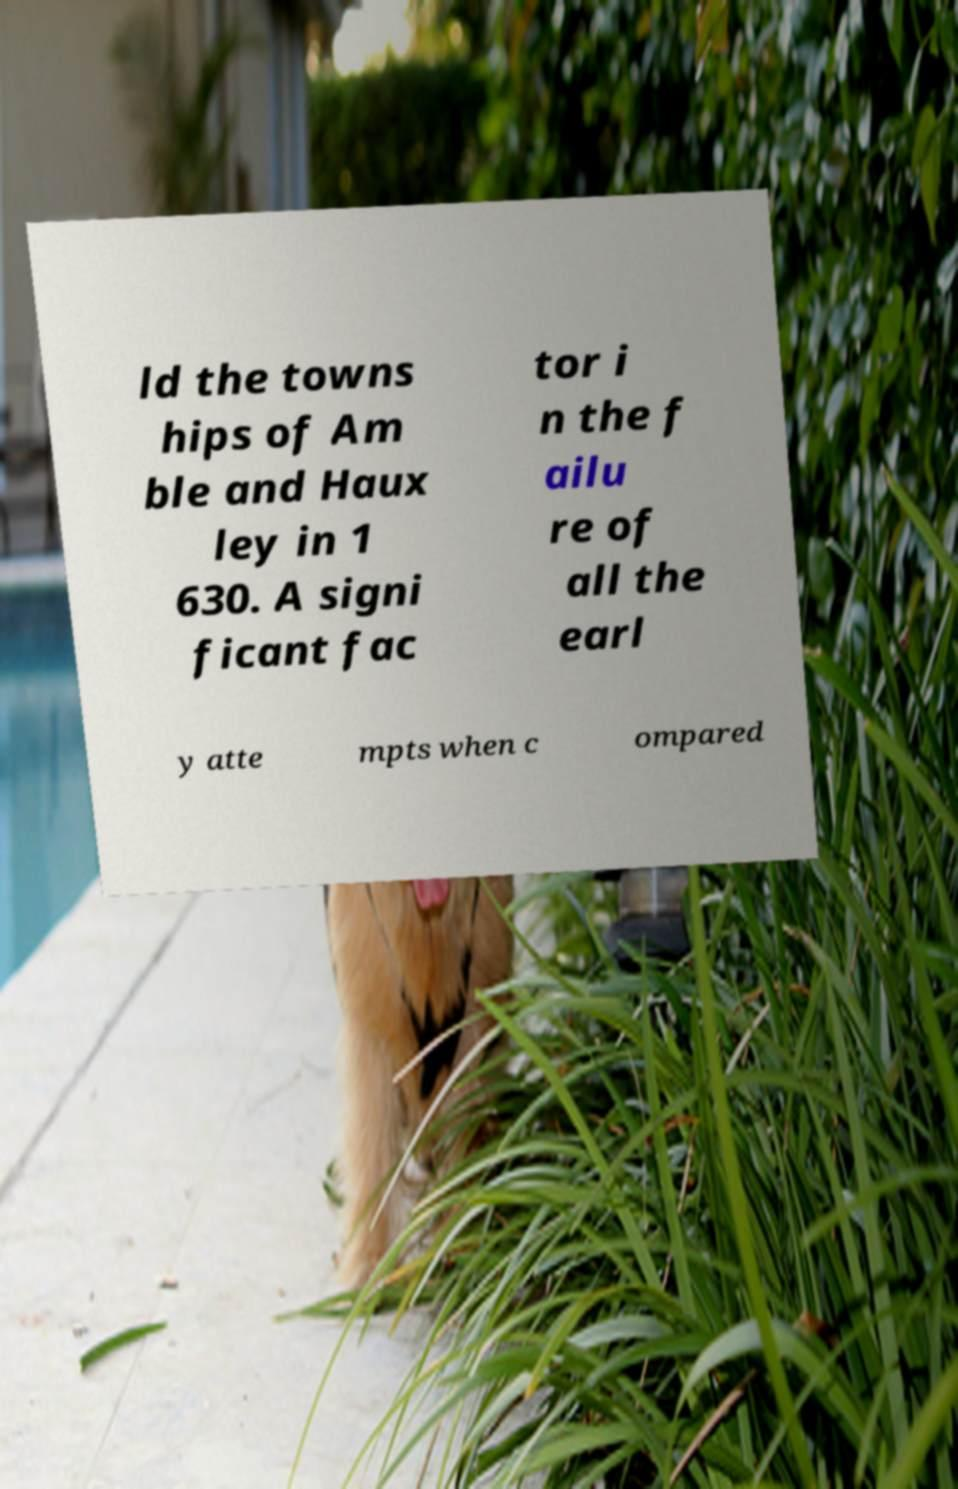I need the written content from this picture converted into text. Can you do that? ld the towns hips of Am ble and Haux ley in 1 630. A signi ficant fac tor i n the f ailu re of all the earl y atte mpts when c ompared 